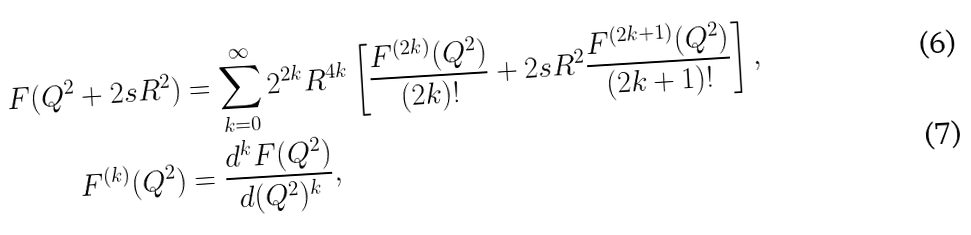Convert formula to latex. <formula><loc_0><loc_0><loc_500><loc_500>F ( Q ^ { 2 } + 2 s R ^ { 2 } ) & = \sum _ { k = 0 } ^ { \infty } 2 ^ { 2 k } R ^ { 4 k } \left [ \frac { F ^ { ( 2 k ) } ( Q ^ { 2 } ) } { ( 2 k ) ! } + 2 s R ^ { 2 } \frac { F ^ { ( 2 k + 1 ) } ( Q ^ { 2 } ) } { ( 2 k + 1 ) ! } \right ] , \\ F ^ { ( k ) } ( Q ^ { 2 } ) & = \frac { d ^ { k } F ( Q ^ { 2 } ) } { d ( Q ^ { 2 } ) ^ { k } } ,</formula> 